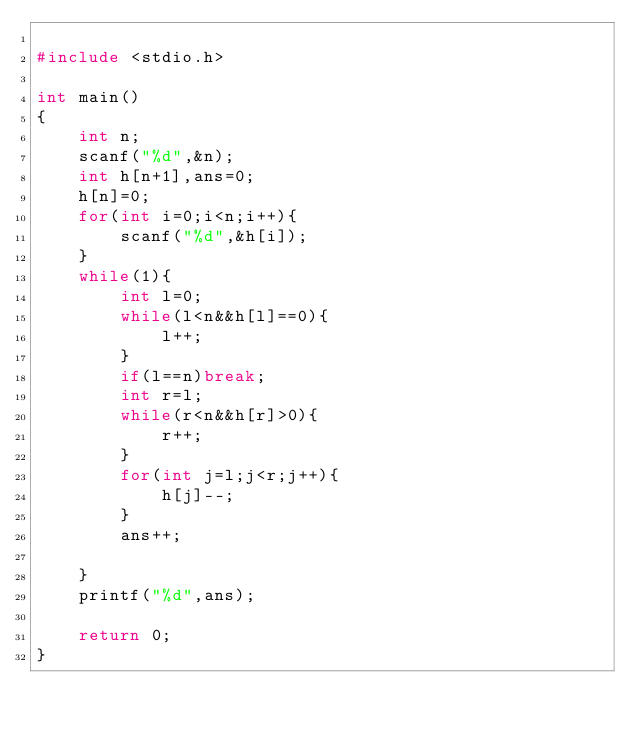<code> <loc_0><loc_0><loc_500><loc_500><_C_>
#include <stdio.h>

int main()
{
    int n;
    scanf("%d",&n);
    int h[n+1],ans=0;
    h[n]=0;
    for(int i=0;i<n;i++){
        scanf("%d",&h[i]);
    }
    while(1){
        int l=0;
        while(l<n&&h[l]==0){
            l++;
        }
        if(l==n)break;
        int r=l;
        while(r<n&&h[r]>0){
            r++;
        }
        for(int j=l;j<r;j++){
            h[j]--;
        }
        ans++;
        
    }
    printf("%d",ans);

    return 0;
}
</code> 